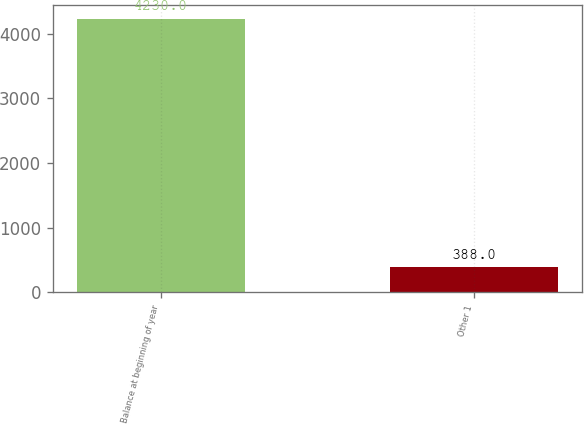Convert chart to OTSL. <chart><loc_0><loc_0><loc_500><loc_500><bar_chart><fcel>Balance at beginning of year<fcel>Other 1<nl><fcel>4230<fcel>388<nl></chart> 